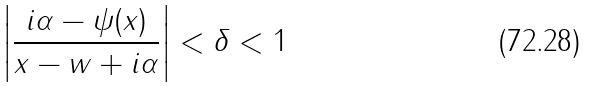<formula> <loc_0><loc_0><loc_500><loc_500>\left | \frac { i \alpha - \psi ( x ) } { x - w + i \alpha } \right | < \delta < 1</formula> 